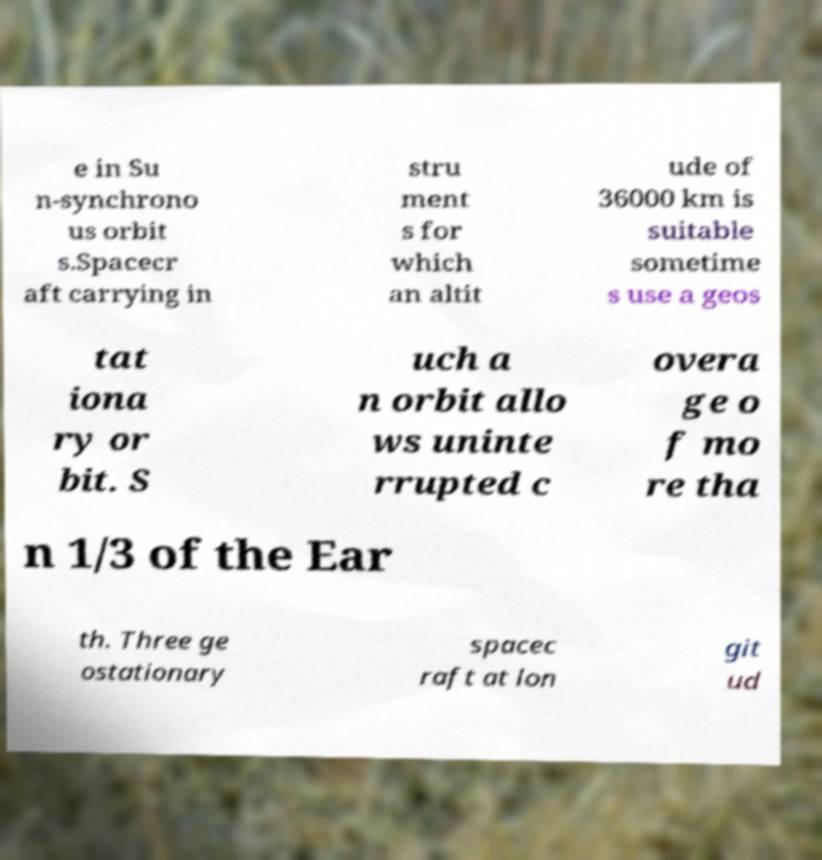Could you assist in decoding the text presented in this image and type it out clearly? e in Su n-synchrono us orbit s.Spacecr aft carrying in stru ment s for which an altit ude of 36000 km is suitable sometime s use a geos tat iona ry or bit. S uch a n orbit allo ws uninte rrupted c overa ge o f mo re tha n 1/3 of the Ear th. Three ge ostationary spacec raft at lon git ud 